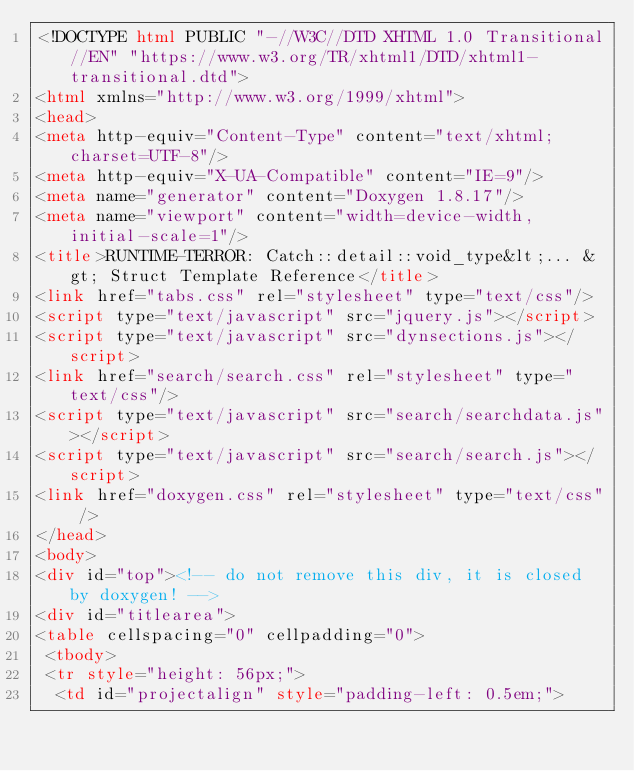<code> <loc_0><loc_0><loc_500><loc_500><_HTML_><!DOCTYPE html PUBLIC "-//W3C//DTD XHTML 1.0 Transitional//EN" "https://www.w3.org/TR/xhtml1/DTD/xhtml1-transitional.dtd">
<html xmlns="http://www.w3.org/1999/xhtml">
<head>
<meta http-equiv="Content-Type" content="text/xhtml;charset=UTF-8"/>
<meta http-equiv="X-UA-Compatible" content="IE=9"/>
<meta name="generator" content="Doxygen 1.8.17"/>
<meta name="viewport" content="width=device-width, initial-scale=1"/>
<title>RUNTIME-TERROR: Catch::detail::void_type&lt;... &gt; Struct Template Reference</title>
<link href="tabs.css" rel="stylesheet" type="text/css"/>
<script type="text/javascript" src="jquery.js"></script>
<script type="text/javascript" src="dynsections.js"></script>
<link href="search/search.css" rel="stylesheet" type="text/css"/>
<script type="text/javascript" src="search/searchdata.js"></script>
<script type="text/javascript" src="search/search.js"></script>
<link href="doxygen.css" rel="stylesheet" type="text/css" />
</head>
<body>
<div id="top"><!-- do not remove this div, it is closed by doxygen! -->
<div id="titlearea">
<table cellspacing="0" cellpadding="0">
 <tbody>
 <tr style="height: 56px;">
  <td id="projectalign" style="padding-left: 0.5em;"></code> 